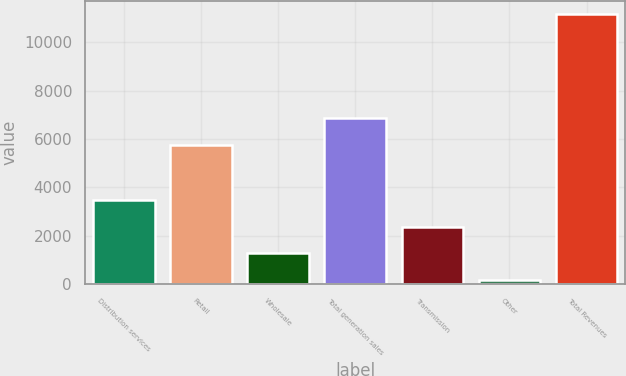<chart> <loc_0><loc_0><loc_500><loc_500><bar_chart><fcel>Distribution services<fcel>Retail<fcel>Wholesale<fcel>Total generation sales<fcel>Transmission<fcel>Other<fcel>Total Revenues<nl><fcel>3475.5<fcel>5760<fcel>1284.5<fcel>6855.5<fcel>2380<fcel>189<fcel>11144<nl></chart> 